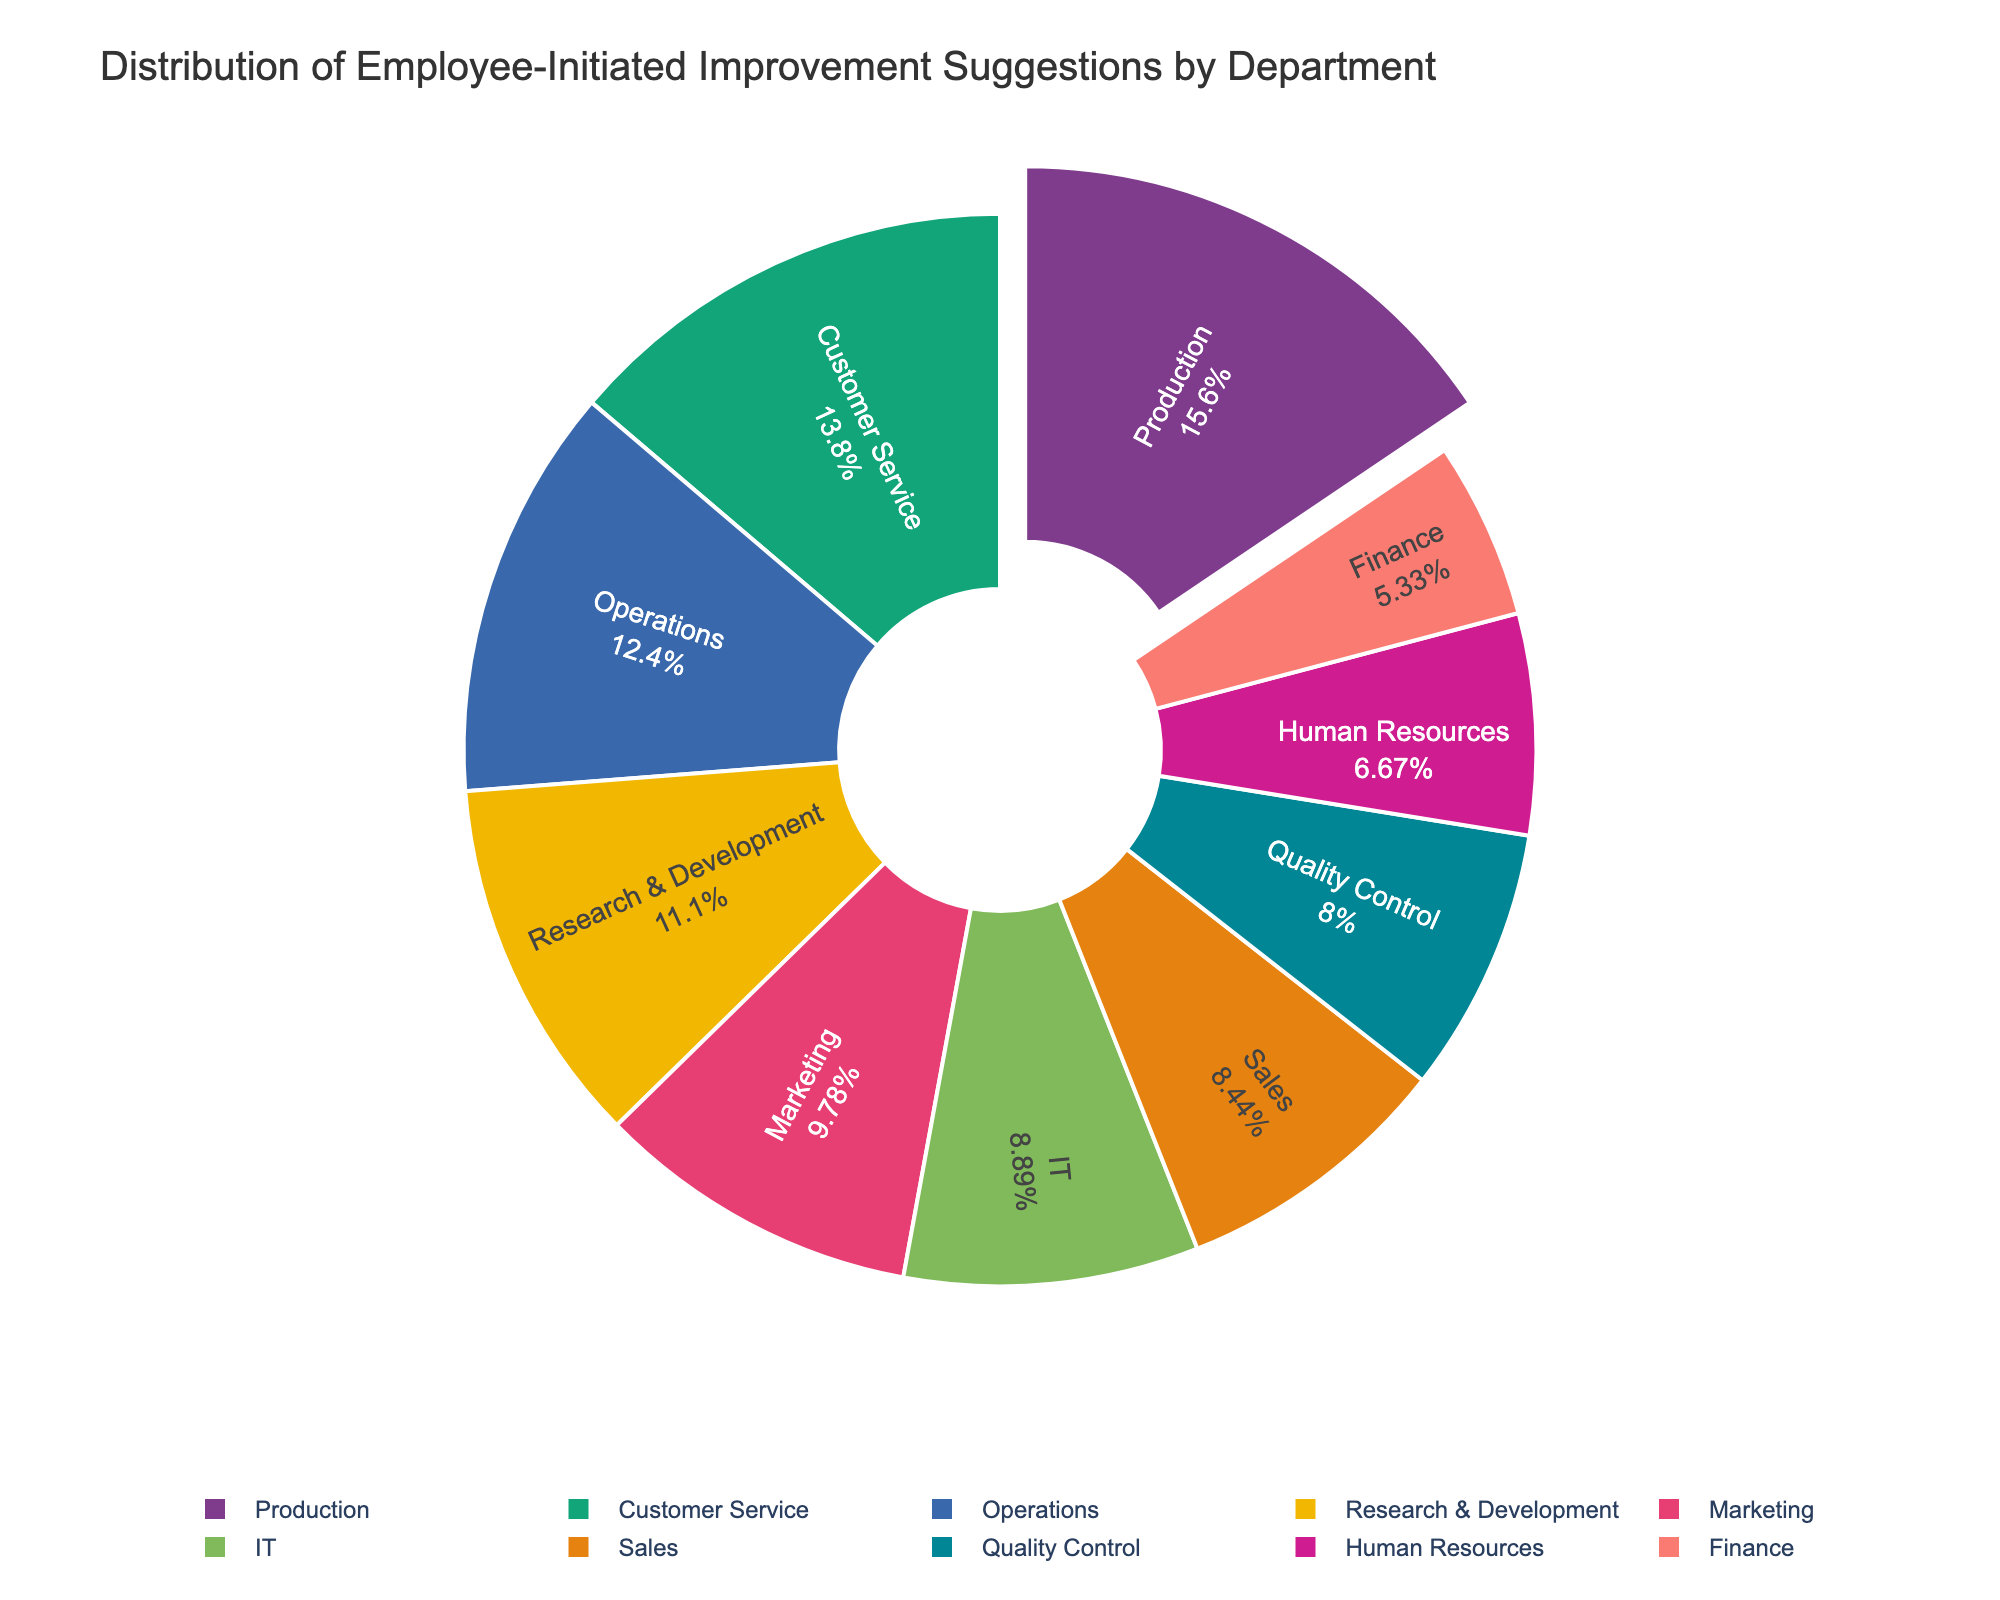What department has the highest number of employee-initiated improvement suggestions? By observing the pie chart, Production has the largest section, indicating it has the highest number of suggestions (35).
Answer: Production Which department has the smallest share of improvement suggestions? The pie chart shows that Finance has the smallest section, indicating it has the fewest suggestions (12).
Answer: Finance Compare the number of suggestions between Research & Development and IT. Which one has more? From the pie chart, Research & Development has 25 suggestions and IT has 20 suggestions, so Research & Development has more.
Answer: Research & Development What is the combined percentage of suggestions from Operations, Marketing, and Sales? To find the combined percentage, sum the suggestions (28 + 22 + 19 = 69) and divide by the total (225), then multiply by 100. (69/225)*100 ≈ 30.67%.
Answer: 30.67% Which department's share in the pie chart is closest to 10% of all suggestions? Finance has 12 suggestions out of 225 total; (12/225)*100 = 5.33%, which is closest to 10%.
Answer: Finance Which departments have more than 20 suggestions? The pie chart indicates that Operations, Marketing, Customer Service, Research & Development, and Production all have more than 20 suggestions.
Answer: Operations, Marketing, Customer Service, Research & Development, Production How many more suggestions does Customer Service have compared to Sales? Customer Service has 31 suggestions and Sales has 19 suggestions. The difference is 31 - 19 = 12.
Answer: 12 What is the percentage of improvement suggestions submitted by Customer Service? Customer Service has 31 suggestions out of 225 total. Calculating (31/225)*100 gives approximately 13.78%.
Answer: 13.78% What departments fall under the category of having between 15 and 25 suggestions? The pie chart shows that Human Resources (15), Marketing (22), Sales (19), Research & Development (25), and IT (20) fall within this range.
Answer: Human Resources, Marketing, Sales, Research & Development, IT If we combine the suggestions from Quality Control and Production, what fraction of the total suggestions do they represent? Quality Control has 18 and Production has 35. Summing them gives 53. Thus, the fraction is 53/225.
Answer: 53/225 